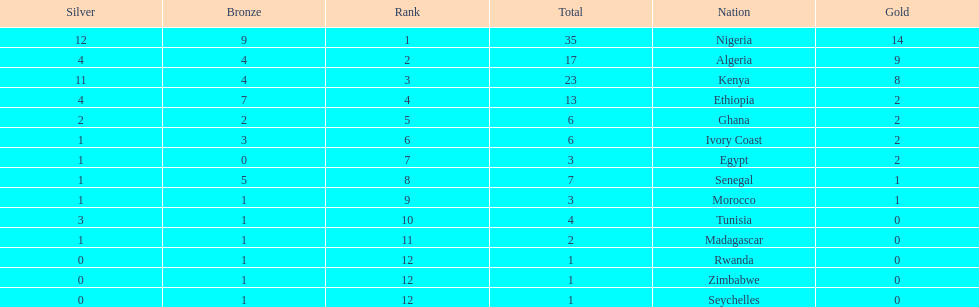The country that won the most medals was? Nigeria. 